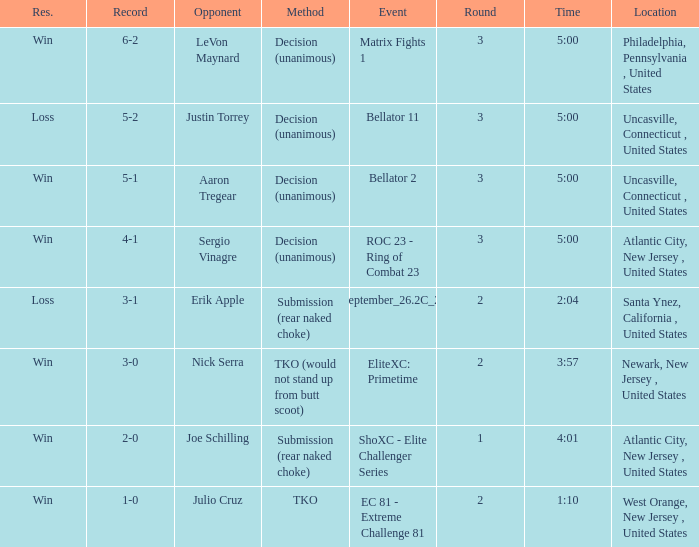What was the round that Sergio Vinagre had a time of 5:00? 3.0. 